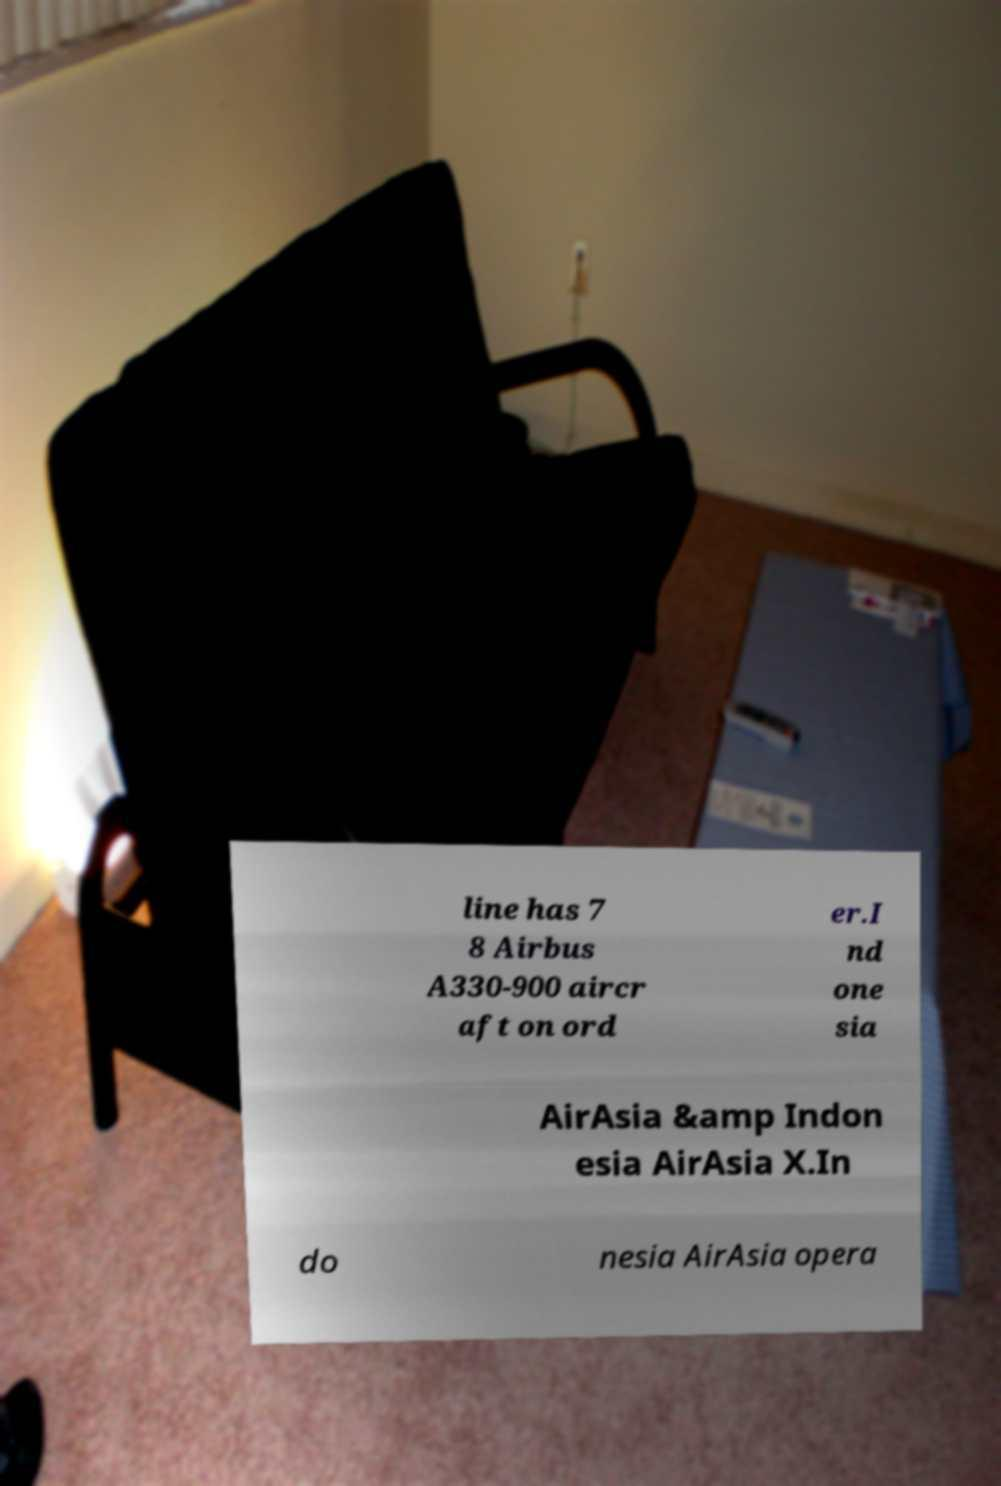I need the written content from this picture converted into text. Can you do that? line has 7 8 Airbus A330-900 aircr aft on ord er.I nd one sia AirAsia &amp Indon esia AirAsia X.In do nesia AirAsia opera 